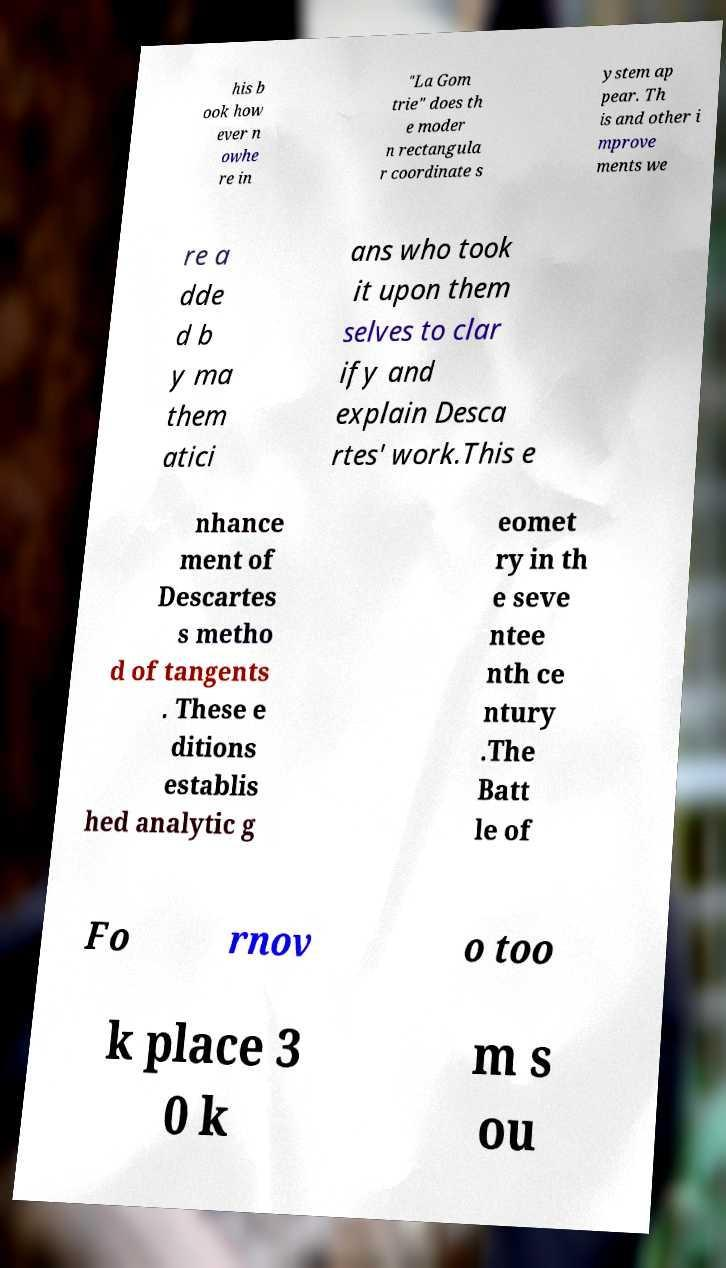Can you accurately transcribe the text from the provided image for me? his b ook how ever n owhe re in "La Gom trie" does th e moder n rectangula r coordinate s ystem ap pear. Th is and other i mprove ments we re a dde d b y ma them atici ans who took it upon them selves to clar ify and explain Desca rtes' work.This e nhance ment of Descartes s metho d of tangents . These e ditions establis hed analytic g eomet ry in th e seve ntee nth ce ntury .The Batt le of Fo rnov o too k place 3 0 k m s ou 